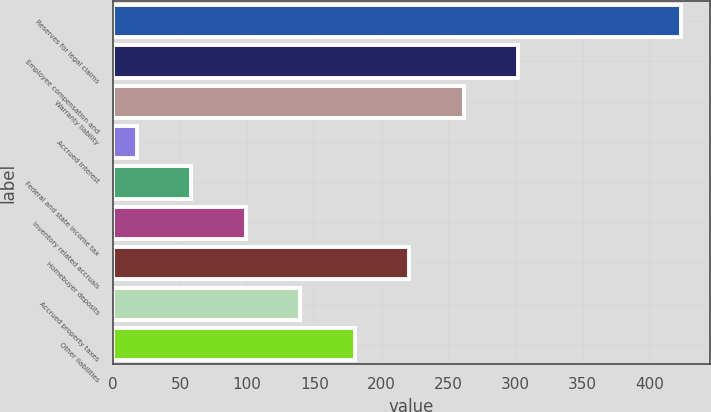Convert chart. <chart><loc_0><loc_0><loc_500><loc_500><bar_chart><fcel>Reserves for legal claims<fcel>Employee compensation and<fcel>Warranty liability<fcel>Accrued interest<fcel>Federal and state income tax<fcel>Inventory related accruals<fcel>Homebuyer deposits<fcel>Accrued property taxes<fcel>Other liabilities<nl><fcel>423.5<fcel>301.82<fcel>261.26<fcel>17.9<fcel>58.46<fcel>99.02<fcel>220.7<fcel>139.58<fcel>180.14<nl></chart> 